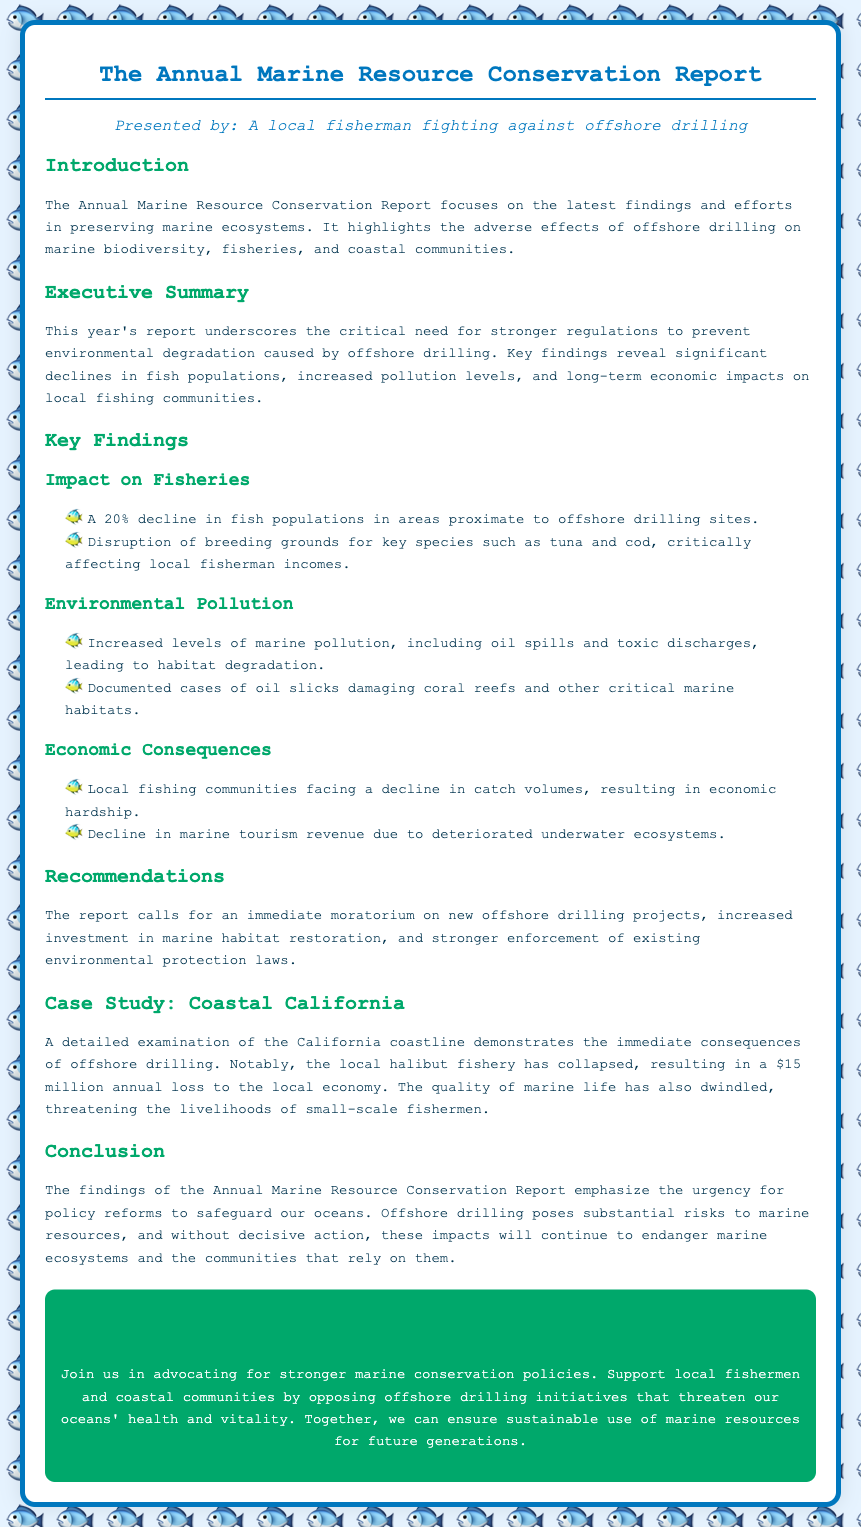What is the main focus of the report? The report focuses on the latest findings and efforts in preserving marine ecosystems, particularly the effects of offshore drilling on marine biodiversity.
Answer: preserving marine ecosystems What percentage decline in fish populations was reported? The document states that there is a 20% decline in fish populations in areas proximate to offshore drilling sites.
Answer: 20% What does the report suggest as an immediate action? The report calls for an immediate moratorium on new offshore drilling projects to protect marine resources.
Answer: moratorium Which local fishery collapsed in the California case study? The detailed examination highlighted the collapse of the local halibut fishery in California.
Answer: halibut What economic impact was reported due to the collapse of the halibut fishery? The local economy saw a loss of $15 million annually due to the collapse of the halibut fishery.
Answer: $15 million What is a major consequence of increased marine pollution mentioned in the report? Documented cases cite oil slicks damaging coral reefs as a significant consequence of increased pollution levels.
Answer: coral reefs What should be strengthened according to the recommendations section? The report emphasizes the need for stronger enforcement of existing environmental protection laws.
Answer: enforcement of laws How does the report characterize the urgency for policy reforms? The findings emphasize the urgency for policy reforms to safeguard oceans against offshore drilling impacts.
Answer: urgency for policy reforms 